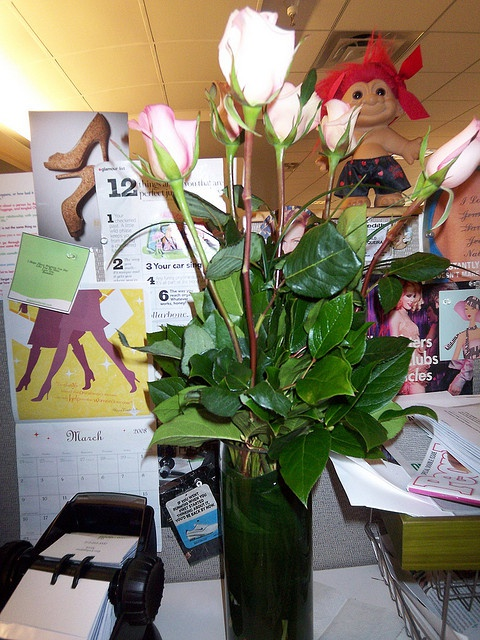Describe the objects in this image and their specific colors. I can see potted plant in khaki, black, darkgreen, white, and olive tones, vase in khaki, black, gray, darkgreen, and maroon tones, and book in khaki, darkgray, lavender, and gray tones in this image. 